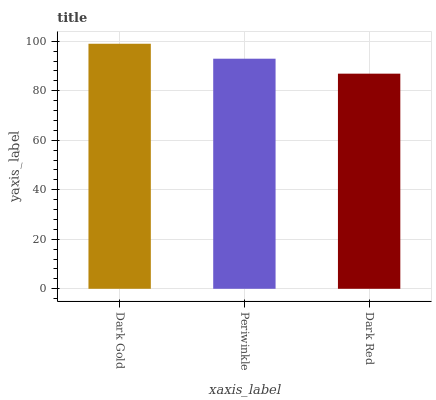Is Dark Red the minimum?
Answer yes or no. Yes. Is Dark Gold the maximum?
Answer yes or no. Yes. Is Periwinkle the minimum?
Answer yes or no. No. Is Periwinkle the maximum?
Answer yes or no. No. Is Dark Gold greater than Periwinkle?
Answer yes or no. Yes. Is Periwinkle less than Dark Gold?
Answer yes or no. Yes. Is Periwinkle greater than Dark Gold?
Answer yes or no. No. Is Dark Gold less than Periwinkle?
Answer yes or no. No. Is Periwinkle the high median?
Answer yes or no. Yes. Is Periwinkle the low median?
Answer yes or no. Yes. Is Dark Gold the high median?
Answer yes or no. No. Is Dark Gold the low median?
Answer yes or no. No. 